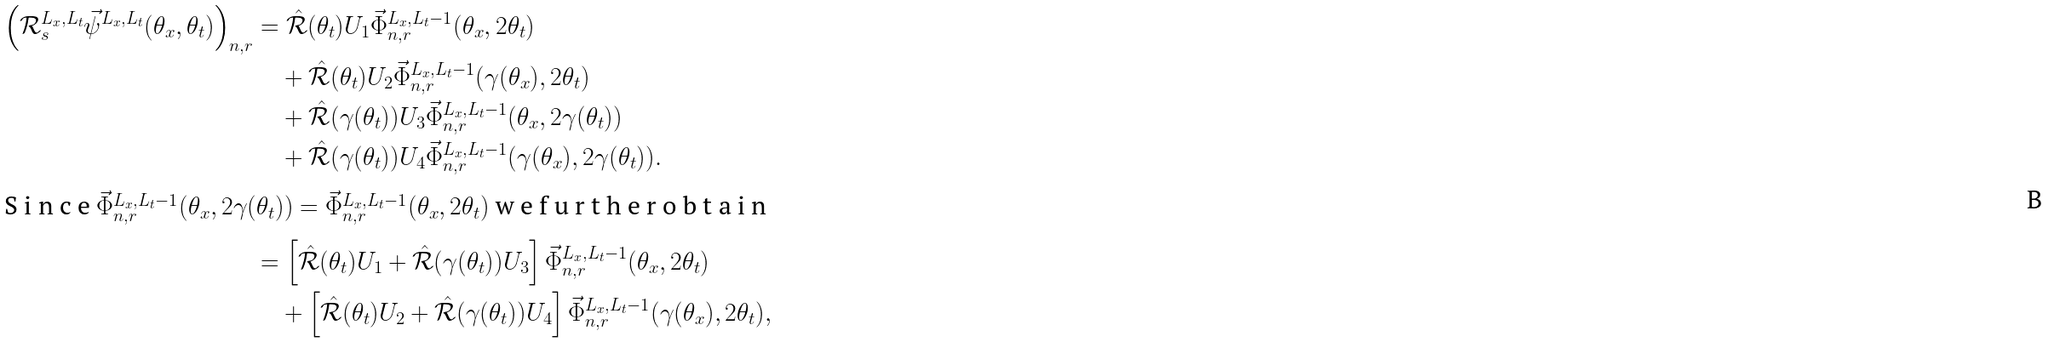Convert formula to latex. <formula><loc_0><loc_0><loc_500><loc_500>\left ( \mathcal { R } _ { s } ^ { L _ { x } , L _ { t } } \vec { \psi } ^ { L _ { x } , L _ { t } } ( \theta _ { x } , \theta _ { t } ) \right ) _ { n , r } & = \hat { \mathcal { R } } ( \theta _ { t } ) U _ { 1 } \vec { \Phi } _ { n , r } ^ { L _ { x } , L _ { t } - 1 } ( \theta _ { x } , 2 \theta _ { t } ) \\ & \quad + \hat { \mathcal { R } } ( \theta _ { t } ) U _ { 2 } \vec { \Phi } _ { n , r } ^ { L _ { x } , L _ { t } - 1 } ( \gamma ( \theta _ { x } ) , 2 \theta _ { t } ) \\ & \quad + \hat { \mathcal { R } } ( \gamma ( \theta _ { t } ) ) U _ { 3 } \vec { \Phi } _ { n , r } ^ { L _ { x } , L _ { t } - 1 } ( \theta _ { x } , 2 \gamma ( \theta _ { t } ) ) \\ & \quad + \hat { \mathcal { R } } ( \gamma ( \theta _ { t } ) ) U _ { 4 } \vec { \Phi } _ { n , r } ^ { L _ { x } , L _ { t } - 1 } ( \gamma ( \theta _ { x } ) , 2 \gamma ( \theta _ { t } ) ) . \intertext { S i n c e $ \vec { \Phi } _ { n , r } ^ { L _ { x } , L _ { t } - 1 } ( \theta _ { x } , 2 \gamma ( \theta _ { t } ) ) = \vec { \Phi } _ { n , r } ^ { L _ { x } , L _ { t } - 1 } ( \theta _ { x } , 2 \theta _ { t } ) $ w e f u r t h e r o b t a i n } & = \left [ \hat { \mathcal { R } } ( \theta _ { t } ) U _ { 1 } + \hat { \mathcal { R } } ( \gamma ( \theta _ { t } ) ) U _ { 3 } \right ] \vec { \Phi } _ { n , r } ^ { L _ { x } , L _ { t } - 1 } ( \theta _ { x } , 2 \theta _ { t } ) \\ & \quad + \left [ \hat { \mathcal { R } } ( \theta _ { t } ) U _ { 2 } + \hat { \mathcal { R } } ( \gamma ( \theta _ { t } ) ) U _ { 4 } \right ] \vec { \Phi } _ { n , r } ^ { L _ { x } , L _ { t } - 1 } ( \gamma ( \theta _ { x } ) , 2 \theta _ { t } ) ,</formula> 